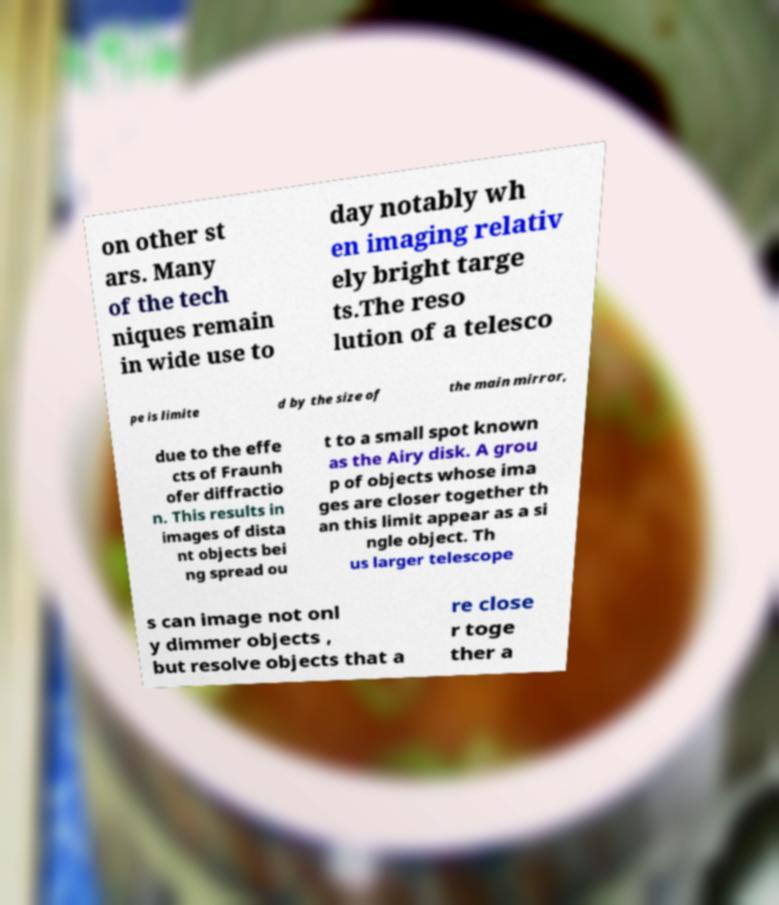Could you assist in decoding the text presented in this image and type it out clearly? on other st ars. Many of the tech niques remain in wide use to day notably wh en imaging relativ ely bright targe ts.The reso lution of a telesco pe is limite d by the size of the main mirror, due to the effe cts of Fraunh ofer diffractio n. This results in images of dista nt objects bei ng spread ou t to a small spot known as the Airy disk. A grou p of objects whose ima ges are closer together th an this limit appear as a si ngle object. Th us larger telescope s can image not onl y dimmer objects , but resolve objects that a re close r toge ther a 